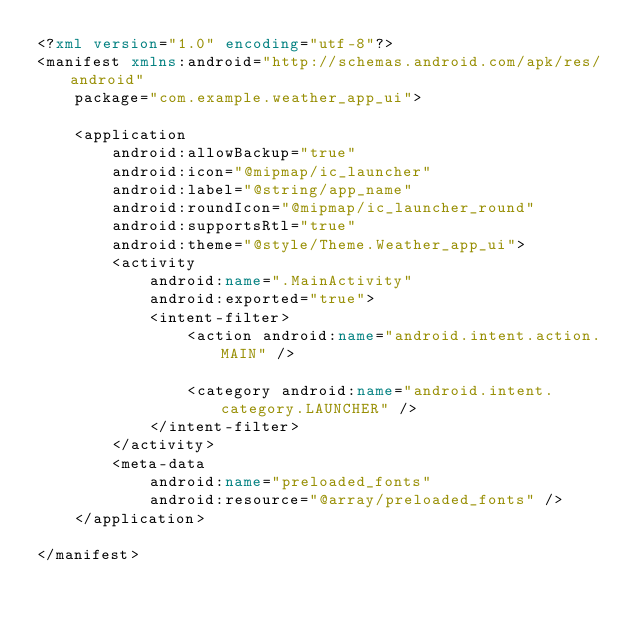<code> <loc_0><loc_0><loc_500><loc_500><_XML_><?xml version="1.0" encoding="utf-8"?>
<manifest xmlns:android="http://schemas.android.com/apk/res/android"
    package="com.example.weather_app_ui">

    <application
        android:allowBackup="true"
        android:icon="@mipmap/ic_launcher"
        android:label="@string/app_name"
        android:roundIcon="@mipmap/ic_launcher_round"
        android:supportsRtl="true"
        android:theme="@style/Theme.Weather_app_ui">
        <activity
            android:name=".MainActivity"
            android:exported="true">
            <intent-filter>
                <action android:name="android.intent.action.MAIN" />

                <category android:name="android.intent.category.LAUNCHER" />
            </intent-filter>
        </activity>
        <meta-data
            android:name="preloaded_fonts"
            android:resource="@array/preloaded_fonts" />
    </application>

</manifest></code> 